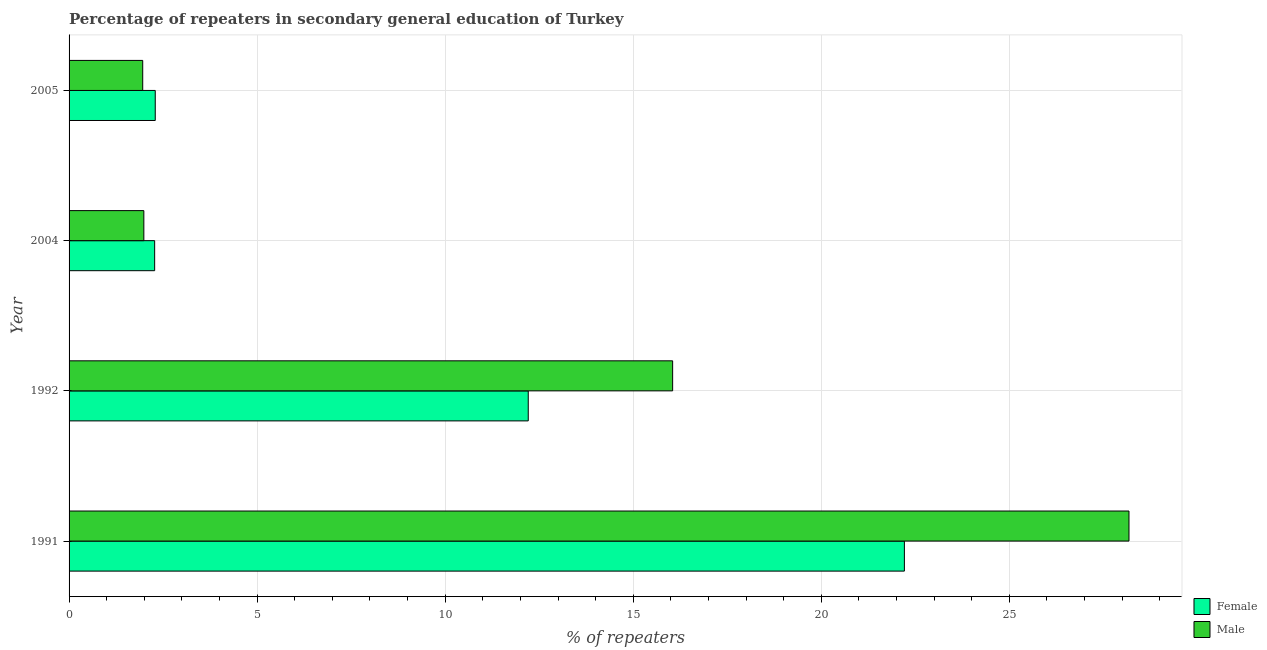How many bars are there on the 2nd tick from the bottom?
Give a very brief answer. 2. In how many cases, is the number of bars for a given year not equal to the number of legend labels?
Offer a terse response. 0. What is the percentage of male repeaters in 2004?
Give a very brief answer. 1.99. Across all years, what is the maximum percentage of female repeaters?
Give a very brief answer. 22.21. Across all years, what is the minimum percentage of male repeaters?
Provide a short and direct response. 1.96. In which year was the percentage of male repeaters maximum?
Give a very brief answer. 1991. What is the total percentage of female repeaters in the graph?
Your answer should be very brief. 38.99. What is the difference between the percentage of female repeaters in 2005 and the percentage of male repeaters in 1992?
Provide a succinct answer. -13.76. What is the average percentage of female repeaters per year?
Your response must be concise. 9.75. In the year 2005, what is the difference between the percentage of female repeaters and percentage of male repeaters?
Make the answer very short. 0.33. In how many years, is the percentage of male repeaters greater than 17 %?
Provide a succinct answer. 1. What is the ratio of the percentage of female repeaters in 1991 to that in 2005?
Keep it short and to the point. 9.69. What is the difference between the highest and the second highest percentage of female repeaters?
Give a very brief answer. 10. What is the difference between the highest and the lowest percentage of female repeaters?
Ensure brevity in your answer.  19.93. Is the sum of the percentage of male repeaters in 2004 and 2005 greater than the maximum percentage of female repeaters across all years?
Your answer should be compact. No. How many bars are there?
Offer a very short reply. 8. Are the values on the major ticks of X-axis written in scientific E-notation?
Provide a short and direct response. No. Where does the legend appear in the graph?
Your response must be concise. Bottom right. What is the title of the graph?
Your answer should be compact. Percentage of repeaters in secondary general education of Turkey. Does "Investment" appear as one of the legend labels in the graph?
Your answer should be very brief. No. What is the label or title of the X-axis?
Your response must be concise. % of repeaters. What is the label or title of the Y-axis?
Provide a short and direct response. Year. What is the % of repeaters in Female in 1991?
Ensure brevity in your answer.  22.21. What is the % of repeaters of Male in 1991?
Provide a succinct answer. 28.18. What is the % of repeaters of Female in 1992?
Your answer should be compact. 12.21. What is the % of repeaters in Male in 1992?
Ensure brevity in your answer.  16.05. What is the % of repeaters in Female in 2004?
Your answer should be very brief. 2.28. What is the % of repeaters in Male in 2004?
Ensure brevity in your answer.  1.99. What is the % of repeaters in Female in 2005?
Ensure brevity in your answer.  2.29. What is the % of repeaters of Male in 2005?
Your response must be concise. 1.96. Across all years, what is the maximum % of repeaters of Female?
Offer a terse response. 22.21. Across all years, what is the maximum % of repeaters in Male?
Your answer should be compact. 28.18. Across all years, what is the minimum % of repeaters in Female?
Your answer should be compact. 2.28. Across all years, what is the minimum % of repeaters in Male?
Provide a short and direct response. 1.96. What is the total % of repeaters of Female in the graph?
Keep it short and to the point. 38.99. What is the total % of repeaters in Male in the graph?
Give a very brief answer. 48.18. What is the difference between the % of repeaters of Female in 1991 and that in 1992?
Your answer should be compact. 10. What is the difference between the % of repeaters in Male in 1991 and that in 1992?
Offer a terse response. 12.13. What is the difference between the % of repeaters in Female in 1991 and that in 2004?
Offer a terse response. 19.93. What is the difference between the % of repeaters in Male in 1991 and that in 2004?
Offer a terse response. 26.19. What is the difference between the % of repeaters in Female in 1991 and that in 2005?
Ensure brevity in your answer.  19.92. What is the difference between the % of repeaters in Male in 1991 and that in 2005?
Offer a terse response. 26.22. What is the difference between the % of repeaters in Female in 1992 and that in 2004?
Provide a short and direct response. 9.93. What is the difference between the % of repeaters of Male in 1992 and that in 2004?
Keep it short and to the point. 14.06. What is the difference between the % of repeaters of Female in 1992 and that in 2005?
Your answer should be very brief. 9.92. What is the difference between the % of repeaters of Male in 1992 and that in 2005?
Make the answer very short. 14.09. What is the difference between the % of repeaters in Female in 2004 and that in 2005?
Your answer should be very brief. -0.02. What is the difference between the % of repeaters in Male in 2004 and that in 2005?
Your answer should be compact. 0.03. What is the difference between the % of repeaters in Female in 1991 and the % of repeaters in Male in 1992?
Your response must be concise. 6.16. What is the difference between the % of repeaters in Female in 1991 and the % of repeaters in Male in 2004?
Offer a very short reply. 20.22. What is the difference between the % of repeaters in Female in 1991 and the % of repeaters in Male in 2005?
Give a very brief answer. 20.25. What is the difference between the % of repeaters of Female in 1992 and the % of repeaters of Male in 2004?
Your answer should be compact. 10.22. What is the difference between the % of repeaters of Female in 1992 and the % of repeaters of Male in 2005?
Offer a very short reply. 10.25. What is the difference between the % of repeaters in Female in 2004 and the % of repeaters in Male in 2005?
Your answer should be compact. 0.32. What is the average % of repeaters in Female per year?
Your answer should be very brief. 9.75. What is the average % of repeaters in Male per year?
Give a very brief answer. 12.04. In the year 1991, what is the difference between the % of repeaters of Female and % of repeaters of Male?
Ensure brevity in your answer.  -5.97. In the year 1992, what is the difference between the % of repeaters in Female and % of repeaters in Male?
Provide a succinct answer. -3.84. In the year 2004, what is the difference between the % of repeaters in Female and % of repeaters in Male?
Provide a short and direct response. 0.29. In the year 2005, what is the difference between the % of repeaters of Female and % of repeaters of Male?
Offer a very short reply. 0.33. What is the ratio of the % of repeaters in Female in 1991 to that in 1992?
Provide a succinct answer. 1.82. What is the ratio of the % of repeaters of Male in 1991 to that in 1992?
Your answer should be compact. 1.76. What is the ratio of the % of repeaters in Female in 1991 to that in 2004?
Your answer should be very brief. 9.76. What is the ratio of the % of repeaters of Male in 1991 to that in 2004?
Your answer should be very brief. 14.18. What is the ratio of the % of repeaters in Female in 1991 to that in 2005?
Ensure brevity in your answer.  9.69. What is the ratio of the % of repeaters in Male in 1991 to that in 2005?
Give a very brief answer. 14.39. What is the ratio of the % of repeaters of Female in 1992 to that in 2004?
Make the answer very short. 5.37. What is the ratio of the % of repeaters in Male in 1992 to that in 2004?
Provide a short and direct response. 8.07. What is the ratio of the % of repeaters in Female in 1992 to that in 2005?
Offer a very short reply. 5.33. What is the ratio of the % of repeaters in Male in 1992 to that in 2005?
Offer a very short reply. 8.19. What is the ratio of the % of repeaters of Female in 2004 to that in 2005?
Give a very brief answer. 0.99. What is the ratio of the % of repeaters in Male in 2004 to that in 2005?
Ensure brevity in your answer.  1.02. What is the difference between the highest and the second highest % of repeaters of Female?
Your answer should be very brief. 10. What is the difference between the highest and the second highest % of repeaters in Male?
Ensure brevity in your answer.  12.13. What is the difference between the highest and the lowest % of repeaters in Female?
Provide a short and direct response. 19.93. What is the difference between the highest and the lowest % of repeaters of Male?
Offer a very short reply. 26.22. 